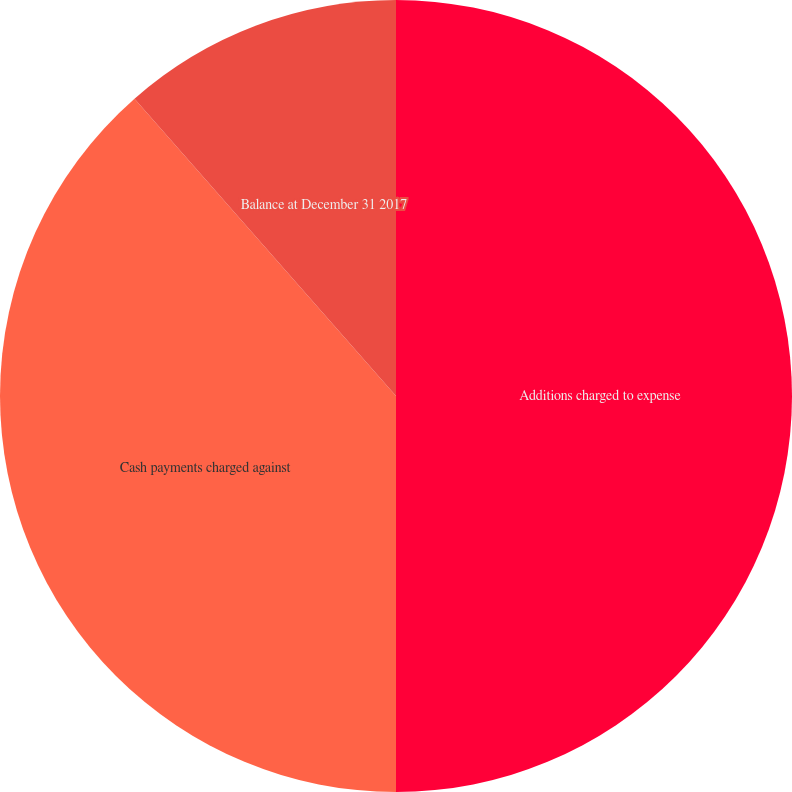Convert chart. <chart><loc_0><loc_0><loc_500><loc_500><pie_chart><fcel>Additions charged to expense<fcel>Cash payments charged against<fcel>Balance at December 31 2017<nl><fcel>50.0%<fcel>38.52%<fcel>11.48%<nl></chart> 